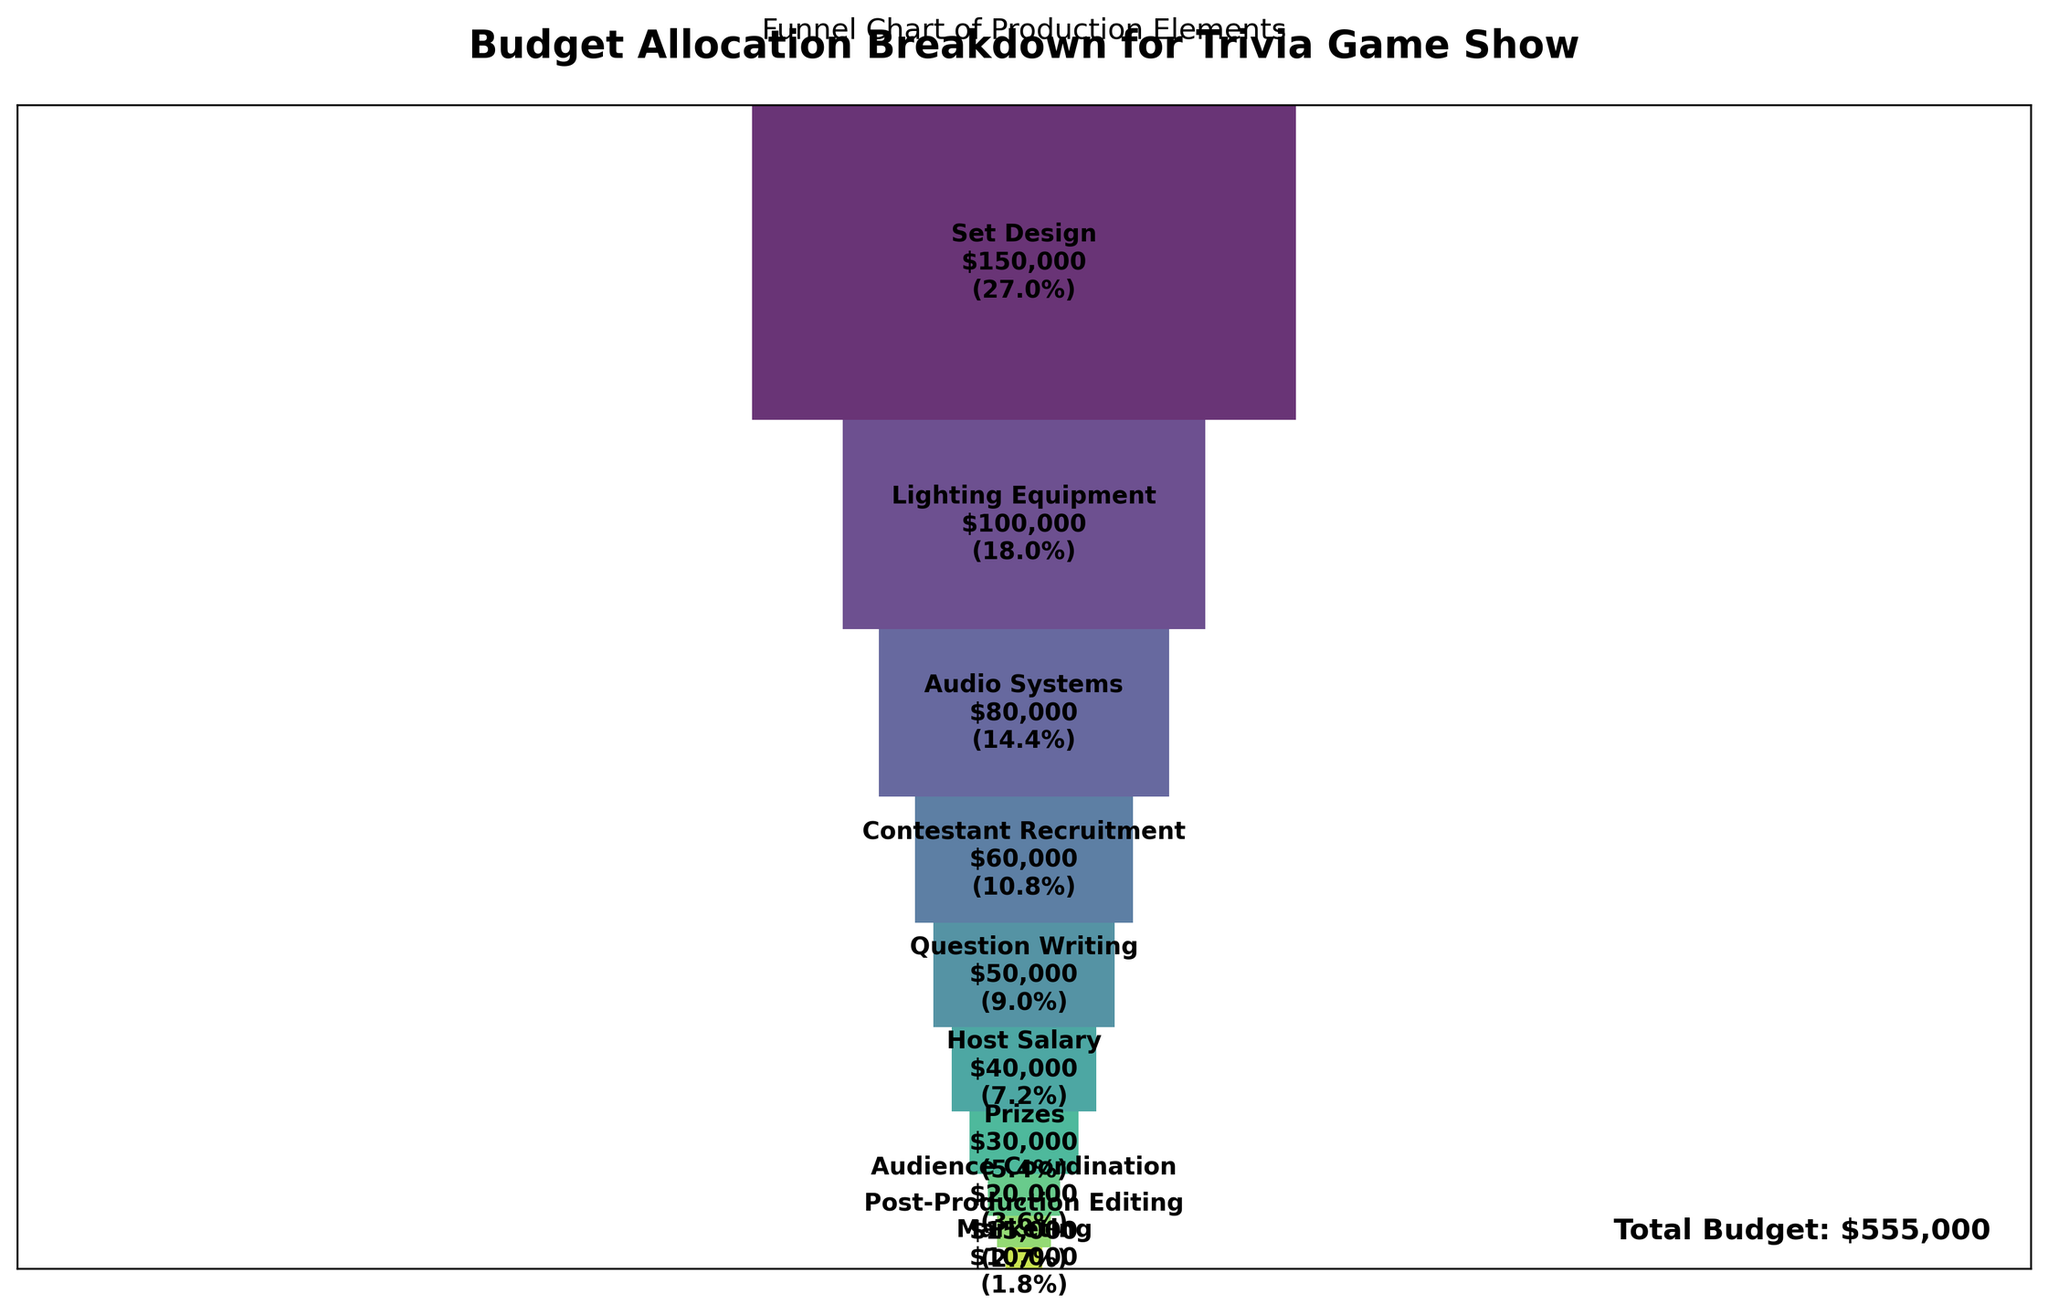What is the title of the funnel chart? The title is generally located at the top of the chart. Looking at the top, we see "Budget Allocation Breakdown for Trivia Game Show".
Answer: Budget Allocation Breakdown for Trivia Game Show Which stage has the highest budget allocation? To determine which stage has the highest budget allocation, observe the topmost segment of the funnel. The top segment represents "Set Design" with $150,000 allocated.
Answer: Set Design What is the total budget for Host Salary and Prizes combined? Locate the budget allocations for Host Salary ($40,000) and Prizes ($30,000), then sum them: $40,000 + $30,000 = $70,000.
Answer: $70,000 How much is allocated to Marketing, and what percentage of the total budget does it represent? The Marketing budget is shown at the bottom of the funnel with an allocation of $10,000. Calculate its percentage by dividing $10,000 by the total budget ($555,000) and multiplying by 100: (10,000 / 555,000) * 100 ≈ 1.8%.
Answer: $10,000 and 1.8% Which stages have a budget allocation larger than Contestant Recruitment? Compare the $60,000 allocation for Contestant Recruitment to other stages. Stages with higher allocations include Set Design, Lighting Equipment, and Audio Systems.
Answer: Set Design, Lighting Equipment, Audio Systems What is the combined budget for all audio-visual related expenses? Sum the budgets for Set Design ($150,000), Lighting Equipment ($100,000), and Audio Systems ($80,000): $150,000 + $100,000 + $80,000 = $330,000.
Answer: $330,000 Is the budget for Audience Coordination greater than, less than, or equal to the budget for Marketing? Compare the budget allocations for Audience Coordination ($20,000) and Marketing ($10,000). Since $20,000 is greater than $10,000, the budget for Audience Coordination is greater.
Answer: Greater Which segment of the funnel represents 10% or less of the total budget? To find a segment with 10% or less, calculate 10% of the total budget ($555,000): 0.10 * 555,000 = $55,500. Segments with allocations of $55,500 or less include Contestant Recruitment, Question Writing, Host Salary, Prizes, Audience Coordination, Post-Production Editing, and Marketing.
Answer: Contestant Recruitment, Question Writing, Host Salary, Prizes, Audience Coordination, Post-Production Editing, Marketing 